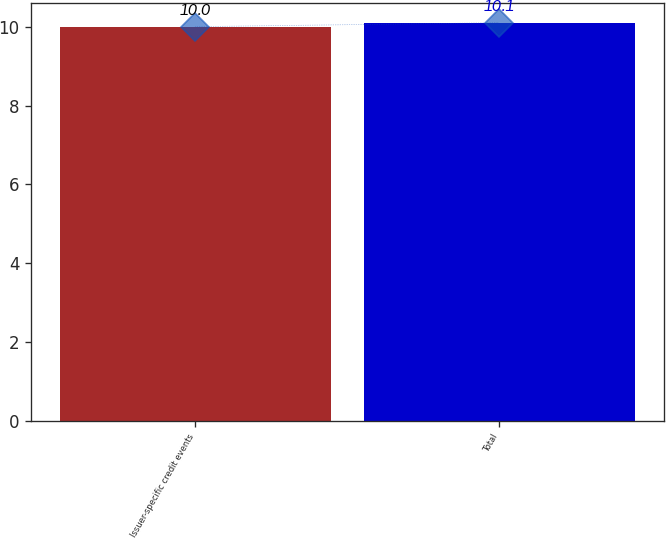<chart> <loc_0><loc_0><loc_500><loc_500><bar_chart><fcel>Issuer-specific credit events<fcel>Total<nl><fcel>10<fcel>10.1<nl></chart> 